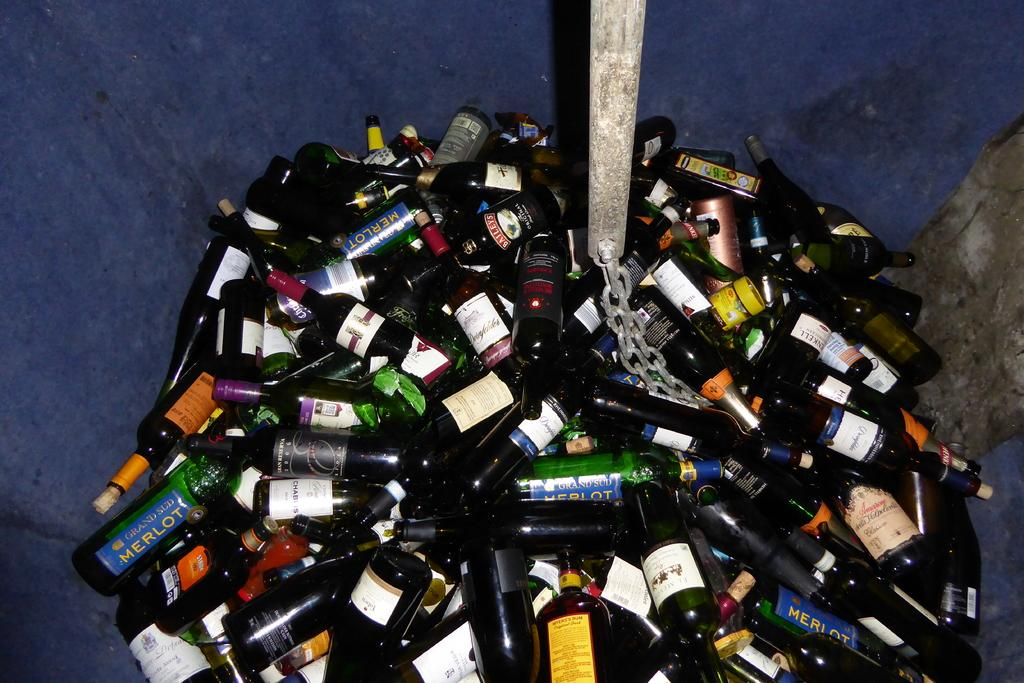Provide a one-sentence caption for the provided image. Large bunch of empty wine bottles with a blue Merlot bottle on the lower left. 